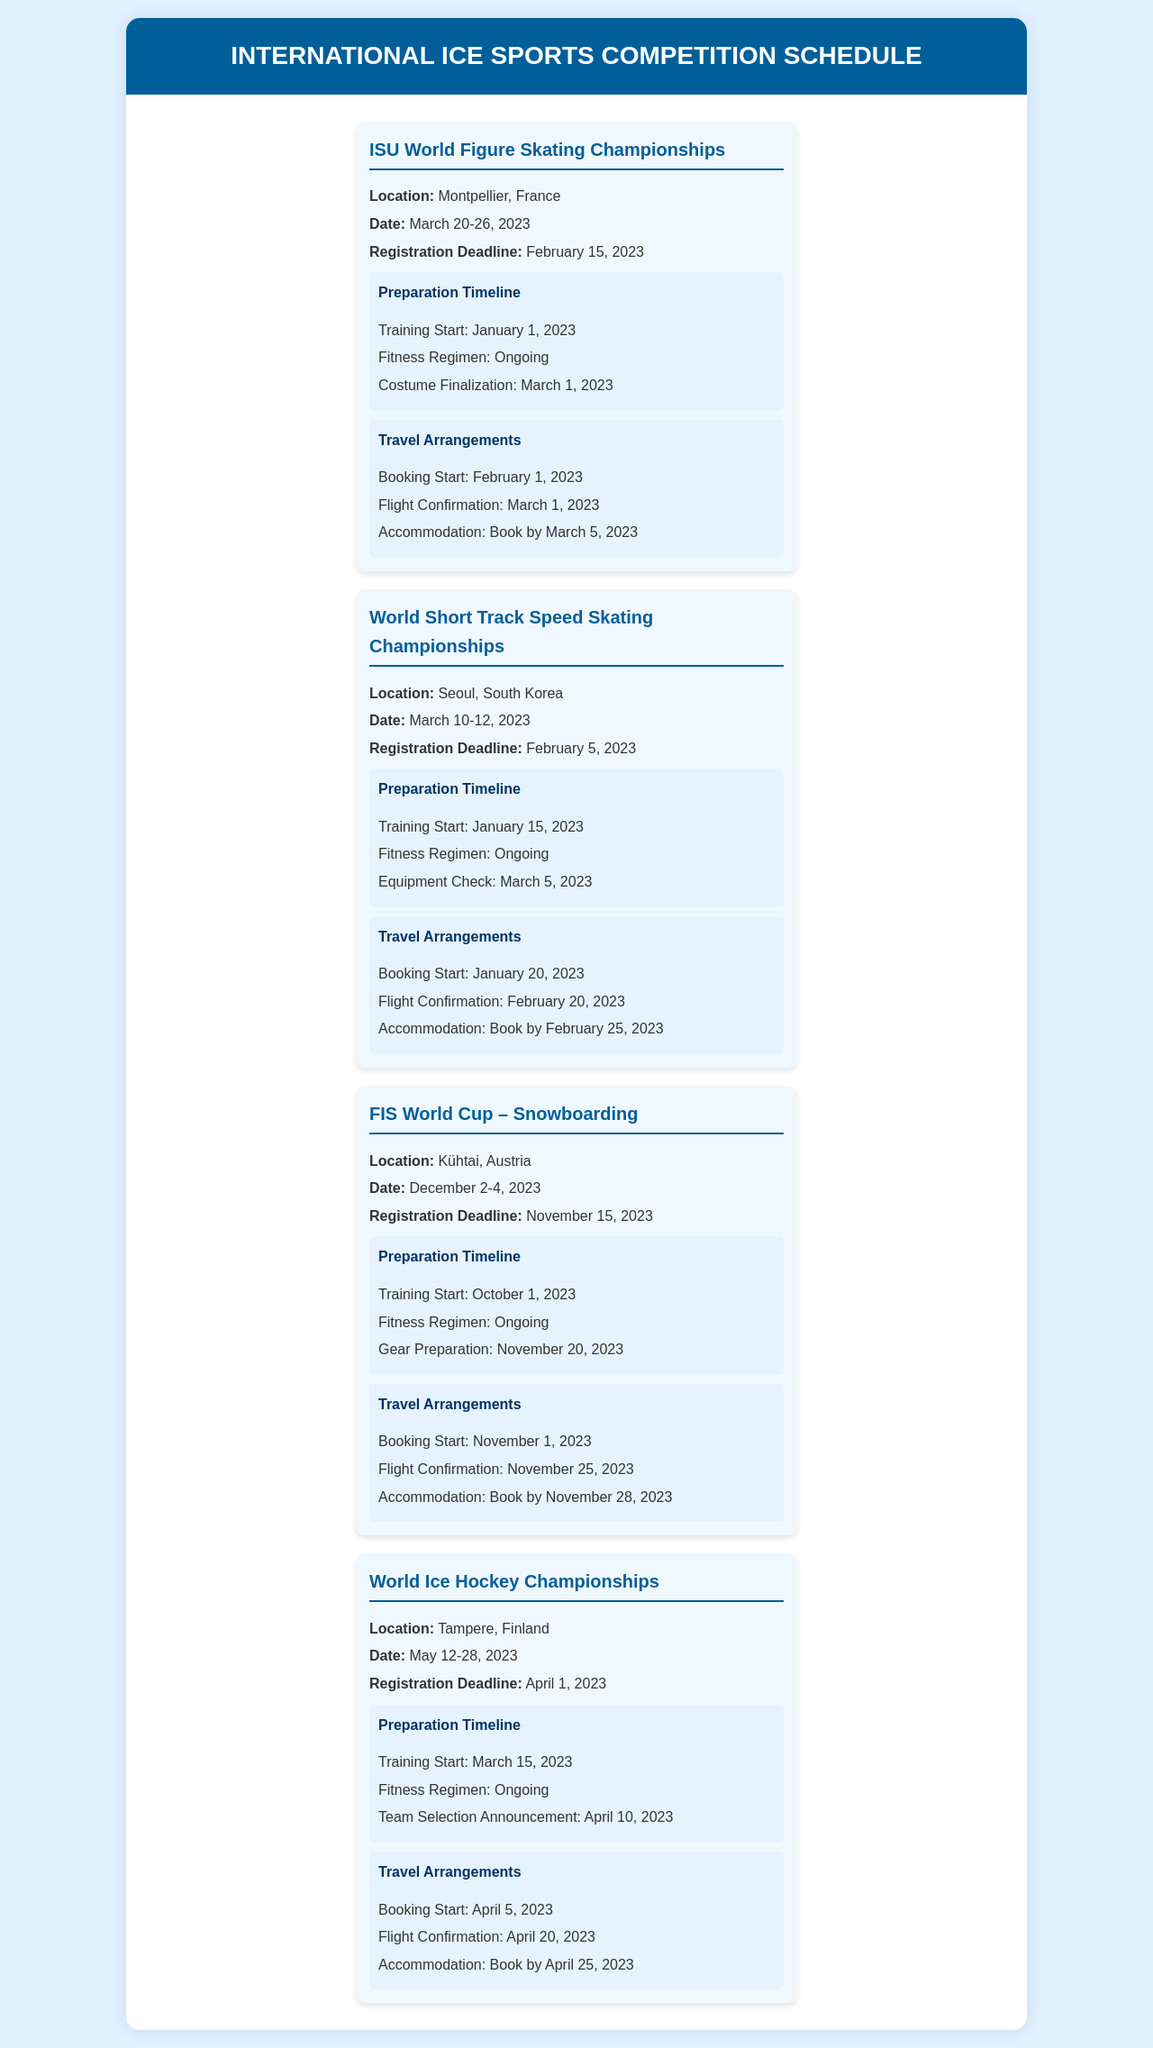what is the location of the ISU World Figure Skating Championships? The location is specified in the event details section of the document.
Answer: Montpellier, France when is the registration deadline for the World Short Track Speed Skating Championships? The registration deadline is mentioned in the event details section.
Answer: February 5, 2023 what is the date range for the FIS World Cup – Snowboarding? The date range is provided in the event details section of the document.
Answer: December 2-4, 2023 what is the training start date for the World Ice Hockey Championships? The training start date is included in the preparation timeline of the event details.
Answer: March 15, 2023 how many days before the event should accommodation be booked for the FIS World Cup – Snowboarding? This requires adding the booking mention date and the event date to calculate the duration.
Answer: 8 days when does the travel booking start for the ISU World Figure Skating Championships? The travel booking information is provided in the travel arrangements section.
Answer: February 1, 2023 which event requires a costume finalization by March 1, 2023? The requirement for costume finalization is mentioned in the preparation timeline.
Answer: ISU World Figure Skating Championships what is a common ongoing task in the preparation timeline across all events? The ongoing tasks are mentioned as part of the preparation timeline for each event.
Answer: Fitness Regimen what document type is this schedule classified as? The type of document is indicated by its title and overall content structure.
Answer: Schedule 